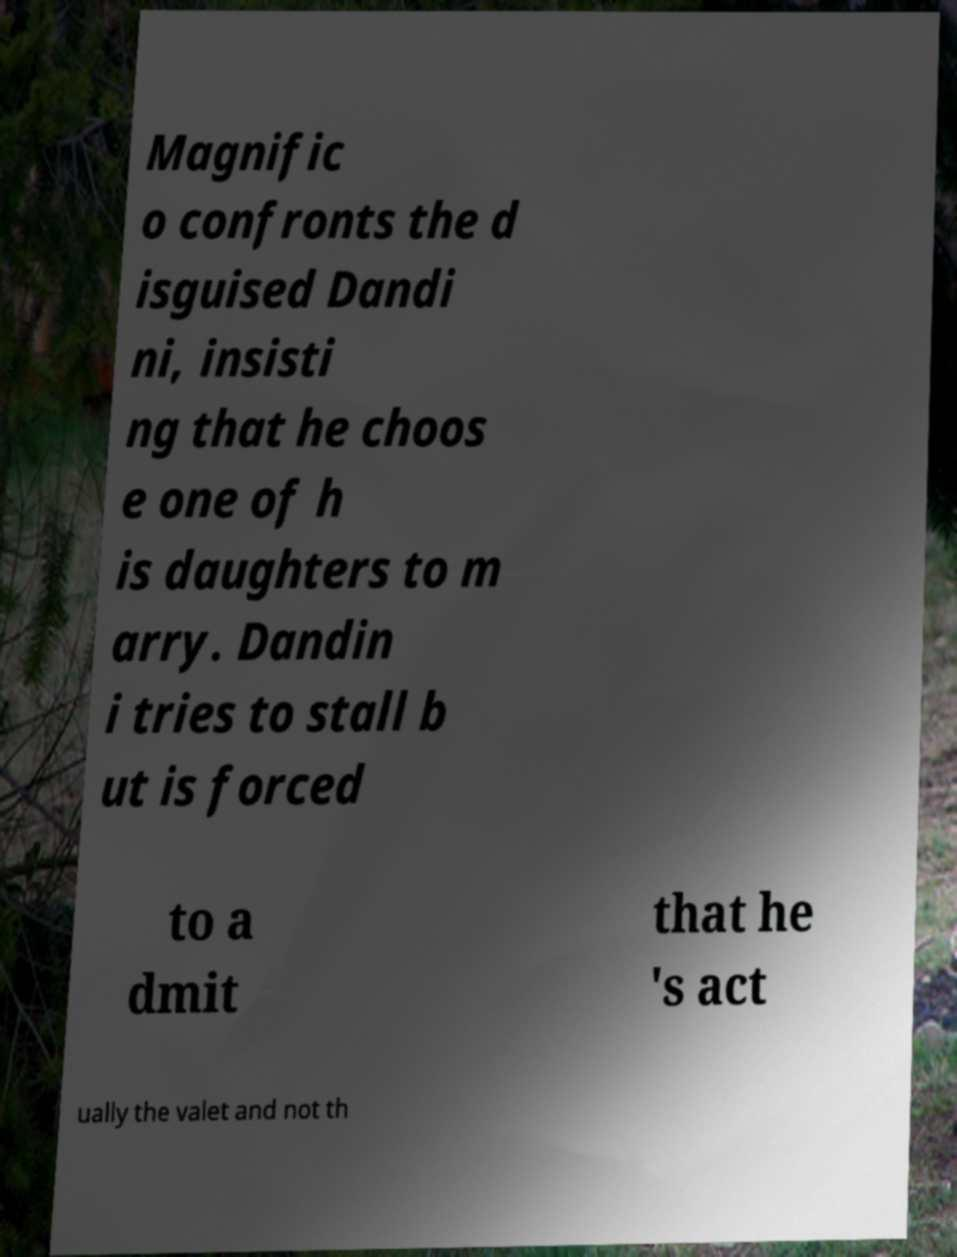Can you accurately transcribe the text from the provided image for me? Magnific o confronts the d isguised Dandi ni, insisti ng that he choos e one of h is daughters to m arry. Dandin i tries to stall b ut is forced to a dmit that he 's act ually the valet and not th 